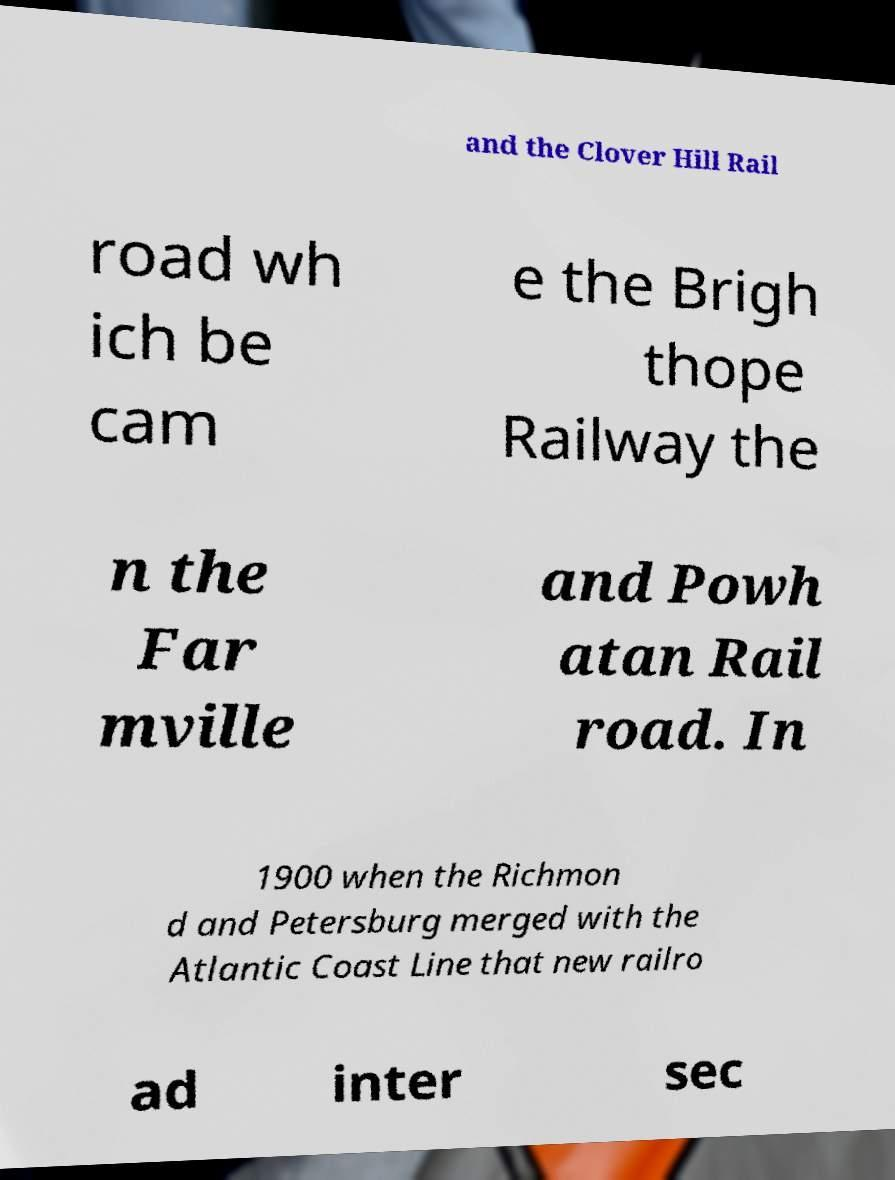I need the written content from this picture converted into text. Can you do that? and the Clover Hill Rail road wh ich be cam e the Brigh thope Railway the n the Far mville and Powh atan Rail road. In 1900 when the Richmon d and Petersburg merged with the Atlantic Coast Line that new railro ad inter sec 